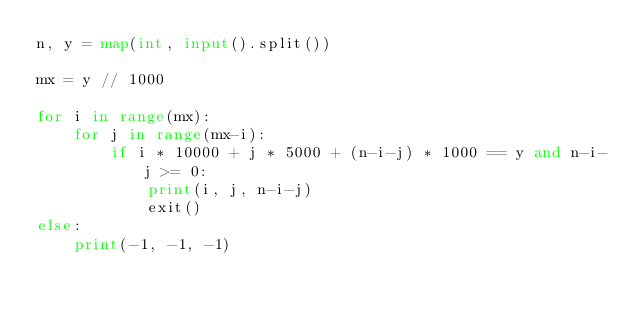Convert code to text. <code><loc_0><loc_0><loc_500><loc_500><_Python_>n, y = map(int, input().split())

mx = y // 1000

for i in range(mx):
    for j in range(mx-i):
        if i * 10000 + j * 5000 + (n-i-j) * 1000 == y and n-i-j >= 0:
            print(i, j, n-i-j)
            exit()
else:
    print(-1, -1, -1)</code> 